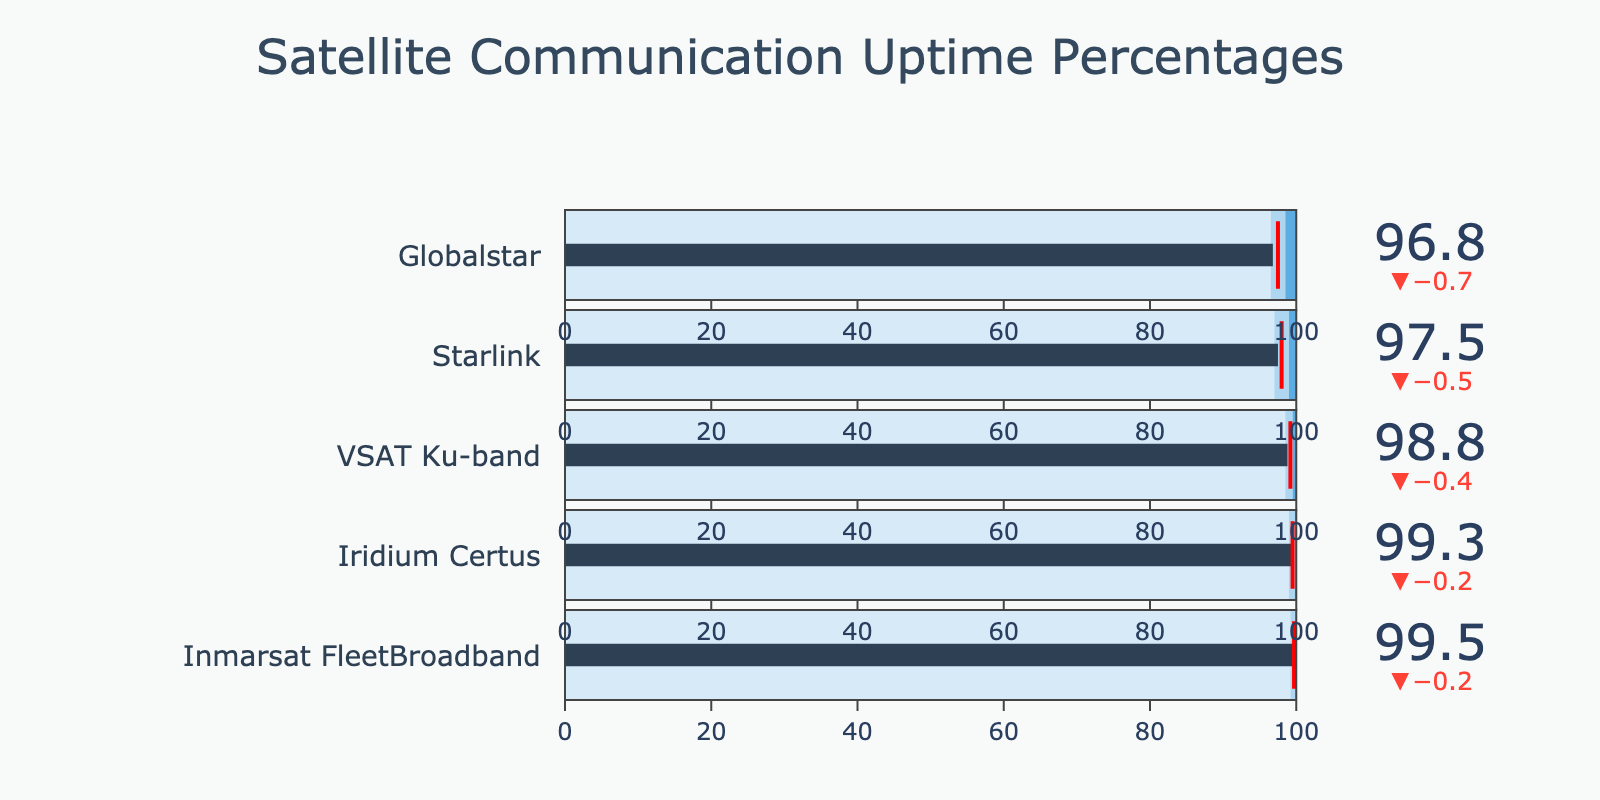What is the actual uptime percentage for Inmarsat FleetBroadband? In the bullet chart, the actual uptime percentage for each communication service is depicted as a bar. For Inmarsat FleetBroadband, this bar shows a value of 99.5%.
Answer: 99.5% Which satellite communication service has the lowest actual uptime percentage? The bullet chart compares multiple services. The service with the lowest actual uptime is Globalstar, represented by a value of 96.8%.
Answer: Globalstar How does the actual uptime of Iridium Certus compare to its target uptime? Iridium Certus has an actual uptime of 99.3%. Its target uptime is represented by a threshold line at 99.5%. To compare, 99.3% is slightly below the target of 99.5%.
Answer: Slightly below Which two satellite communication services have actual uptimes that are above the industry standard but below their respective targets? By comparing the actual uptimes with both the industry standards and target lines, Inmarsat FleetBroadband (99.5% vs. 99.2% industry standard and 99.7% target) and Iridium Certus (99.3% vs. 99.0% industry standard and 99.5% target) fit this criterion.
Answer: Inmarsat FleetBroadband, Iridium Certus What is the difference between the actual uptime and the target uptime for VSAT Ku-band? The actual uptime for VSAT Ku-band is 98.8%, and the target uptime is 99.2%. The difference is calculated as 99.2% - 98.8% = 0.4%.
Answer: 0.4% Which service's actual uptime meets or exceeds the "Excellent" threshold? By examining the end of the colored bar segments (with the darkest color representing "Excellent"), none of the actual uptimes meet or exceed their respective "Excellent" thresholds.
Answer: None How does the actual uptime of Starlink compare to the industry standard for Starlink? Starlink has an actual uptime of 97.5%. The industry standard is 97.0%. Comparing these values, 97.5% is above the industry standard of 97.0%.
Answer: Above Which service has the highest difference between its actual uptime and the industry standard? Calculating the differences: Inmarsat FleetBroadband (99.5% - 99.2% = 0.3%), Iridium Certus (99.3% - 99.0% = 0.3%), VSAT Ku-band (98.8% - 98.5% = 0.3%), Starlink (97.5% - 97.0% = 0.5%), Globalstar (96.8% - 96.5% = 0.3%). Starlink has the highest difference of 0.5%.
Answer: Starlink 